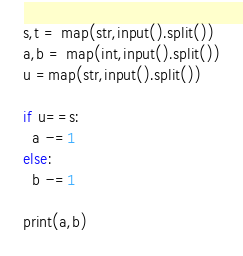Convert code to text. <code><loc_0><loc_0><loc_500><loc_500><_Python_>s,t = map(str,input().split())
a,b = map(int,input().split())
u =map(str,input().split())

if u==s:
  a -=1
else:
  b -=1
  
print(a,b)
</code> 